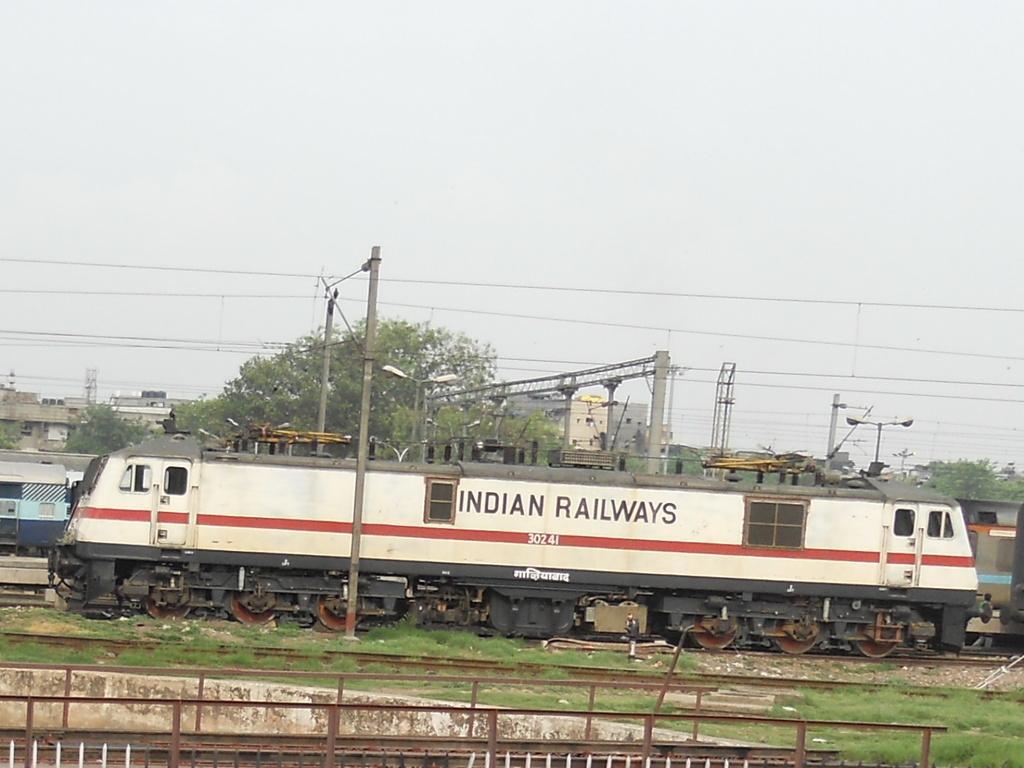How would you summarize this image in a sentence or two? This image is taken in a railway station. In this image we can see the trains, track, grass, electric poles with wires. We can also see the light poles, trees and also the buildings in the background. Sky is also visible in this image. 